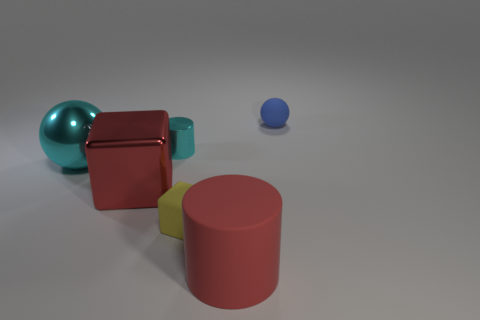Can you describe the arrangement and colors of the shapes in the image? In the image, we have a collection of geometric shapes positioned with some space between them. From left to right, there is a large teal metallic ball, then a deep red matte cube sitting close to a smaller teal matte cube, with a bright red matte cylinder in the foreground, plus a small lemon-colored cube and a smaller royal blue ball in the background. 